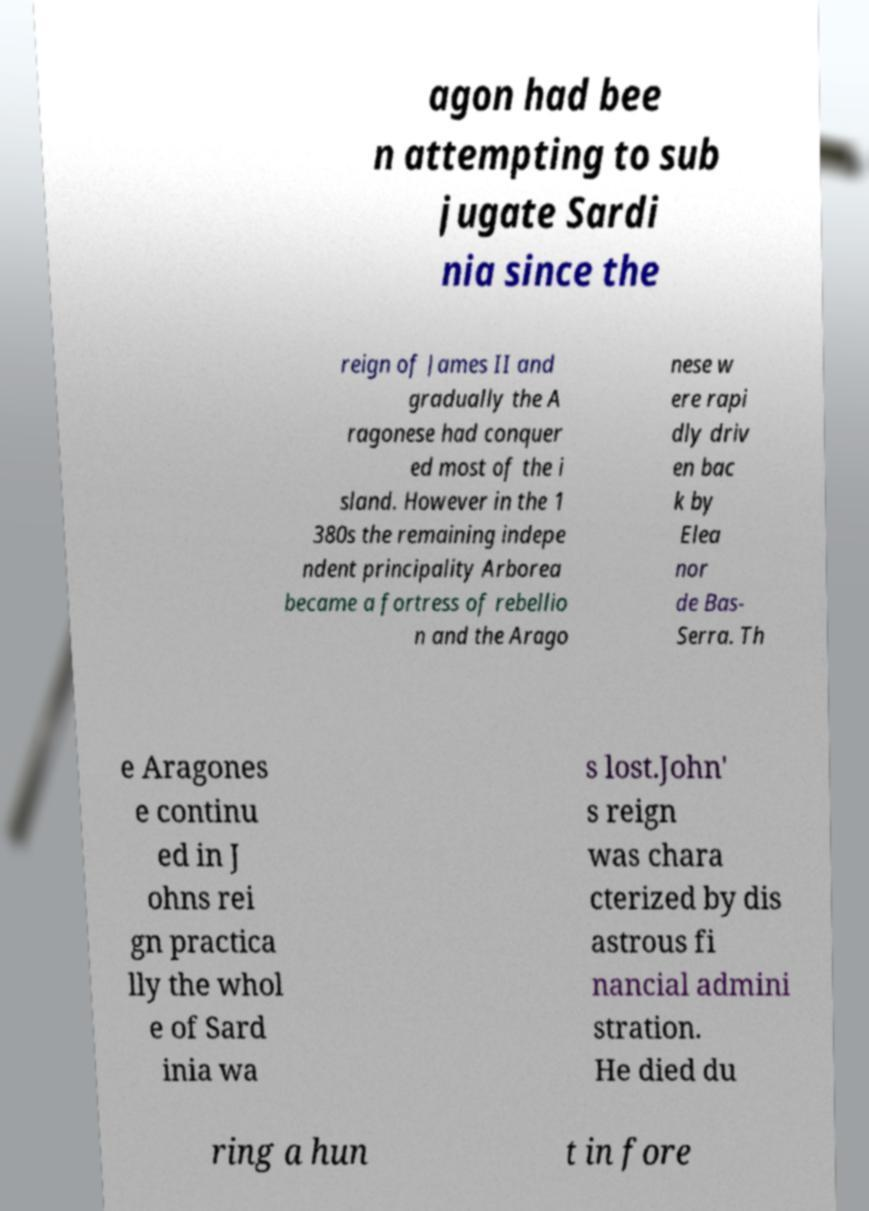Can you read and provide the text displayed in the image?This photo seems to have some interesting text. Can you extract and type it out for me? agon had bee n attempting to sub jugate Sardi nia since the reign of James II and gradually the A ragonese had conquer ed most of the i sland. However in the 1 380s the remaining indepe ndent principality Arborea became a fortress of rebellio n and the Arago nese w ere rapi dly driv en bac k by Elea nor de Bas- Serra. Th e Aragones e continu ed in J ohns rei gn practica lly the whol e of Sard inia wa s lost.John' s reign was chara cterized by dis astrous fi nancial admini stration. He died du ring a hun t in fore 